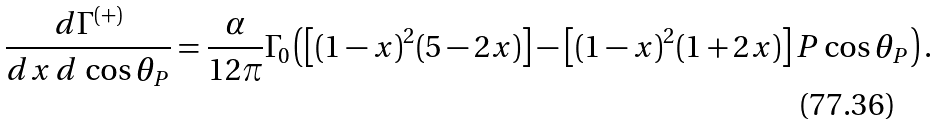<formula> <loc_0><loc_0><loc_500><loc_500>\frac { d \Gamma ^ { ( + ) } } { d x \, d \, \cos \theta _ { P } } = \frac { \alpha } { 1 2 \pi } \Gamma _ { 0 } \left ( \left [ ( 1 - x ) ^ { 2 } ( 5 - 2 x ) \right ] - \left [ ( 1 - x ) ^ { 2 } ( 1 + 2 x ) \right ] P \cos \theta _ { P } \right ) .</formula> 